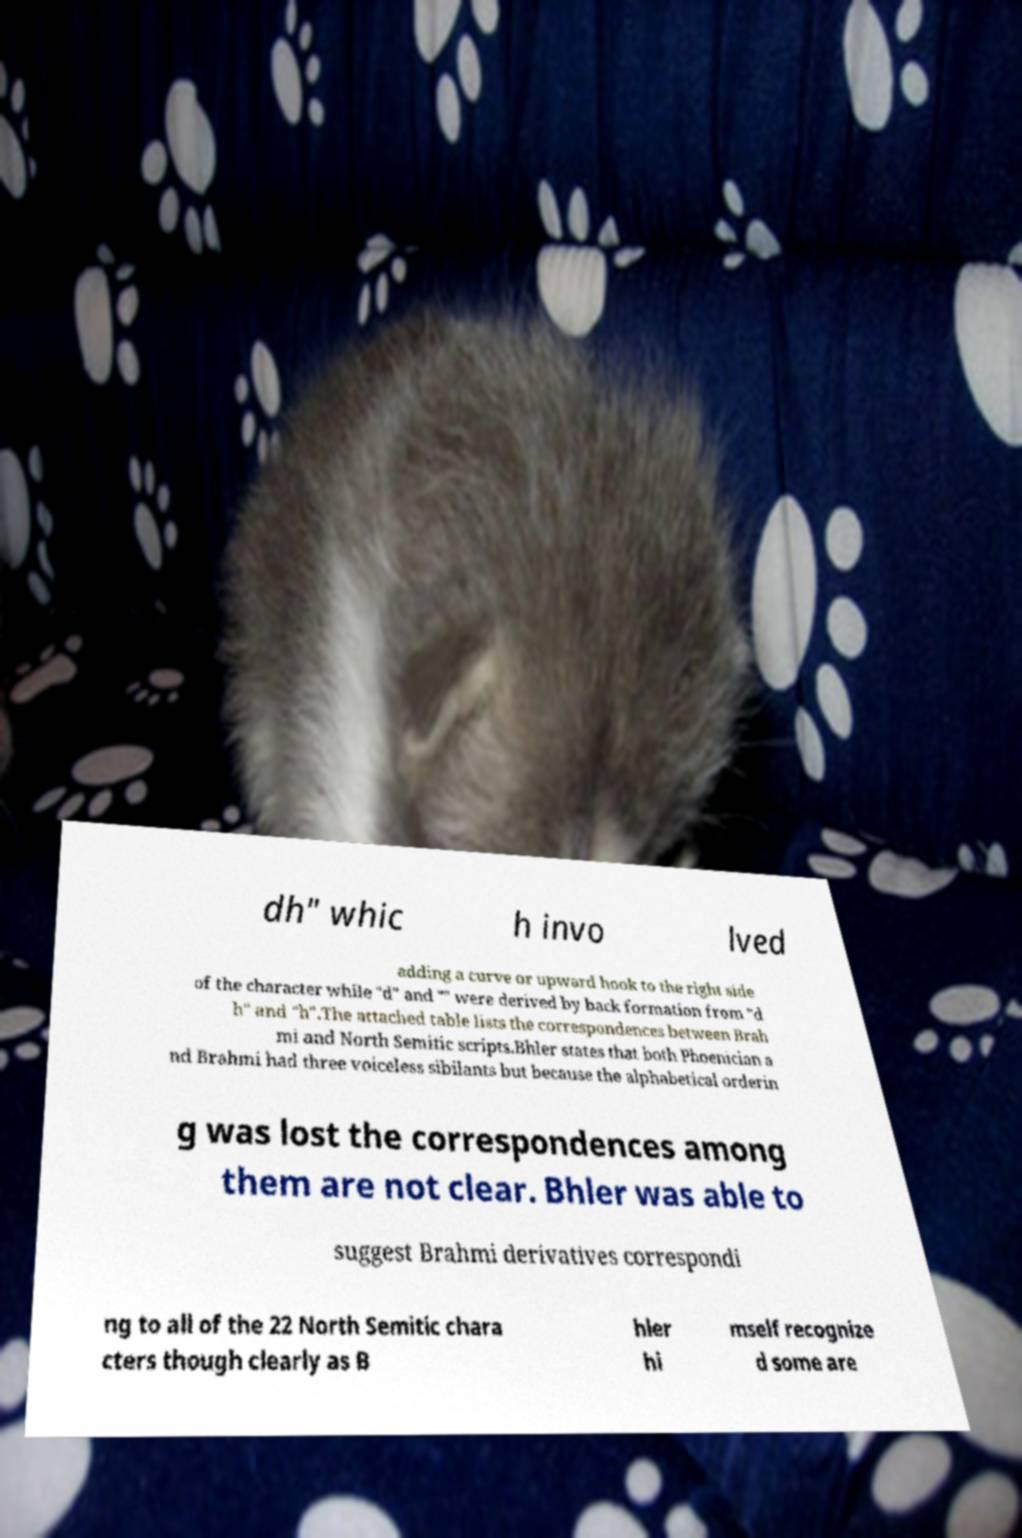Can you accurately transcribe the text from the provided image for me? dh" whic h invo lved adding a curve or upward hook to the right side of the character while "d" and "" were derived by back formation from "d h" and "h".The attached table lists the correspondences between Brah mi and North Semitic scripts.Bhler states that both Phoenician a nd Brahmi had three voiceless sibilants but because the alphabetical orderin g was lost the correspondences among them are not clear. Bhler was able to suggest Brahmi derivatives correspondi ng to all of the 22 North Semitic chara cters though clearly as B hler hi mself recognize d some are 